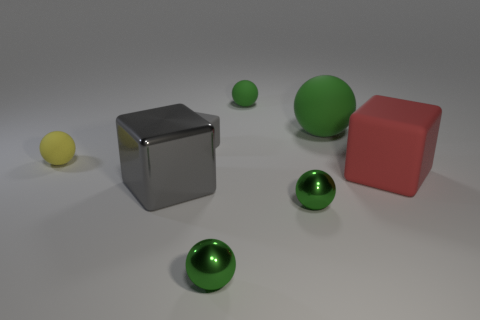Subtract all green balls. How many were subtracted if there are1green balls left? 3 Subtract all tiny rubber cubes. How many cubes are left? 2 Add 2 gray shiny blocks. How many objects exist? 10 Subtract all yellow spheres. How many spheres are left? 4 Subtract all balls. How many objects are left? 3 Subtract 1 spheres. How many spheres are left? 4 Subtract all brown blocks. How many green balls are left? 4 Subtract all red blocks. Subtract all yellow cylinders. How many blocks are left? 2 Subtract all small rubber cubes. Subtract all tiny green rubber spheres. How many objects are left? 6 Add 3 small green shiny objects. How many small green shiny objects are left? 5 